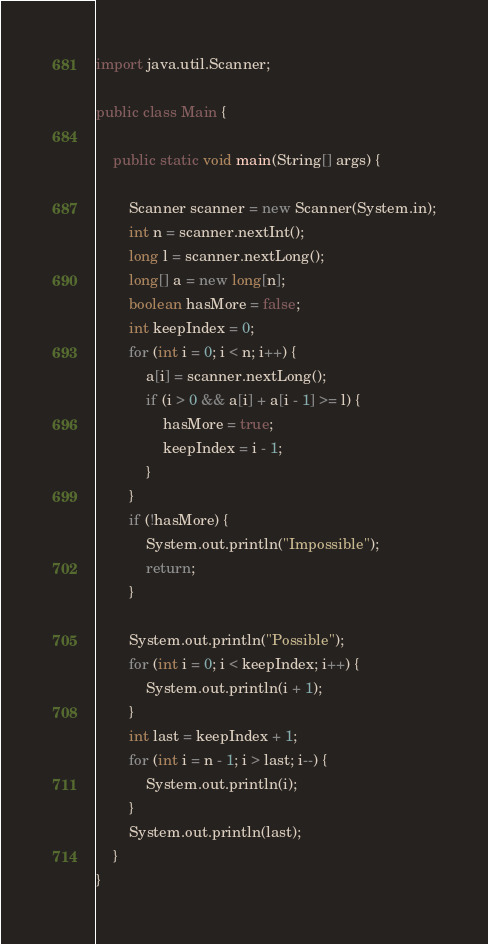Convert code to text. <code><loc_0><loc_0><loc_500><loc_500><_Java_>import java.util.Scanner;

public class Main {

    public static void main(String[] args) {

        Scanner scanner = new Scanner(System.in);
        int n = scanner.nextInt();
        long l = scanner.nextLong();
        long[] a = new long[n];
        boolean hasMore = false;
        int keepIndex = 0;
        for (int i = 0; i < n; i++) {
            a[i] = scanner.nextLong();
            if (i > 0 && a[i] + a[i - 1] >= l) {
                hasMore = true;
                keepIndex = i - 1;
            }
        }
        if (!hasMore) {
            System.out.println("Impossible");
            return;
        }

        System.out.println("Possible");
        for (int i = 0; i < keepIndex; i++) {
            System.out.println(i + 1);
        }
        int last = keepIndex + 1;
        for (int i = n - 1; i > last; i--) {
            System.out.println(i);
        }
        System.out.println(last);
    }
}</code> 